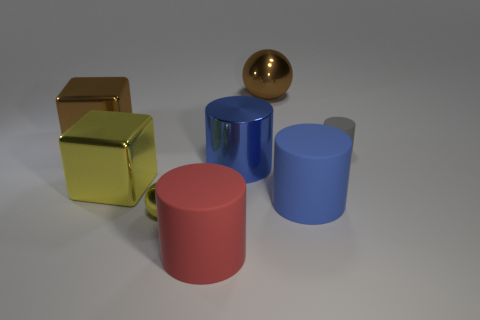Add 1 small red rubber cylinders. How many objects exist? 9 Subtract all metal cylinders. How many cylinders are left? 3 Subtract all purple balls. How many blue cylinders are left? 2 Subtract all blue cylinders. How many cylinders are left? 2 Subtract 2 cubes. How many cubes are left? 0 Subtract all blocks. How many objects are left? 6 Subtract all yellow spheres. Subtract all gray cylinders. How many spheres are left? 1 Subtract all yellow spheres. Subtract all cubes. How many objects are left? 5 Add 3 red objects. How many red objects are left? 4 Add 2 big matte things. How many big matte things exist? 4 